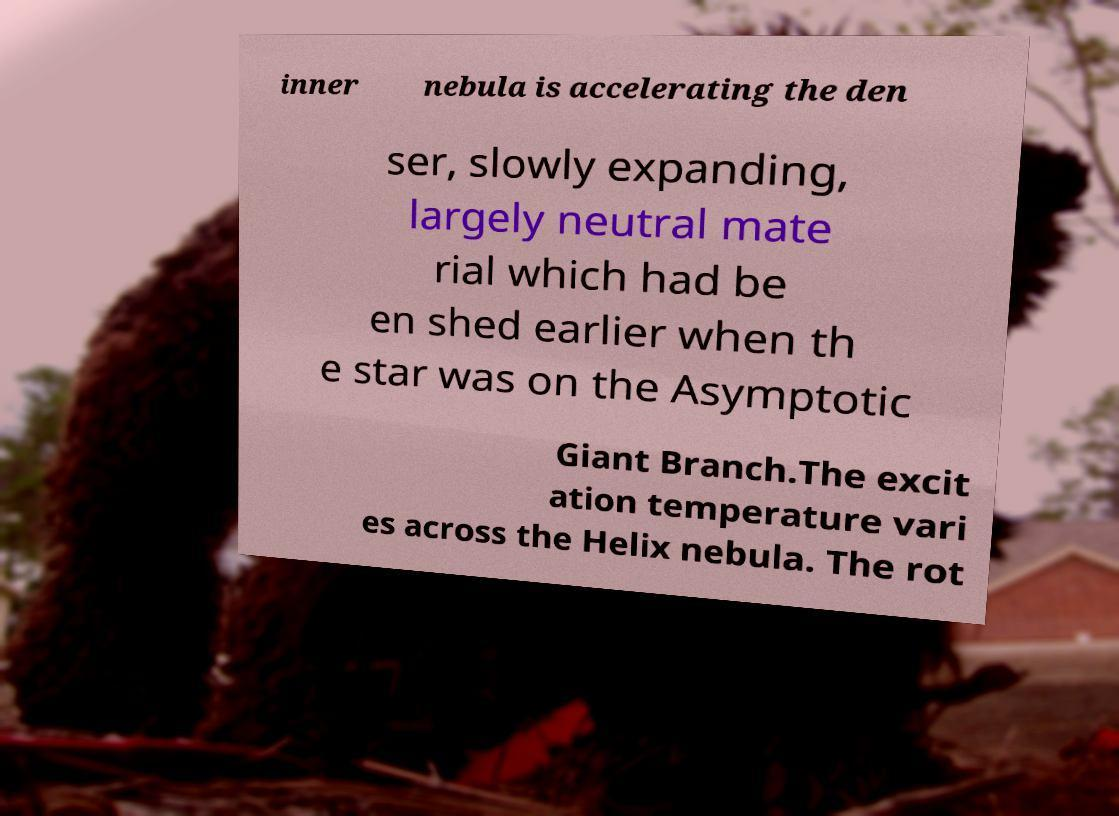Could you extract and type out the text from this image? inner nebula is accelerating the den ser, slowly expanding, largely neutral mate rial which had be en shed earlier when th e star was on the Asymptotic Giant Branch.The excit ation temperature vari es across the Helix nebula. The rot 